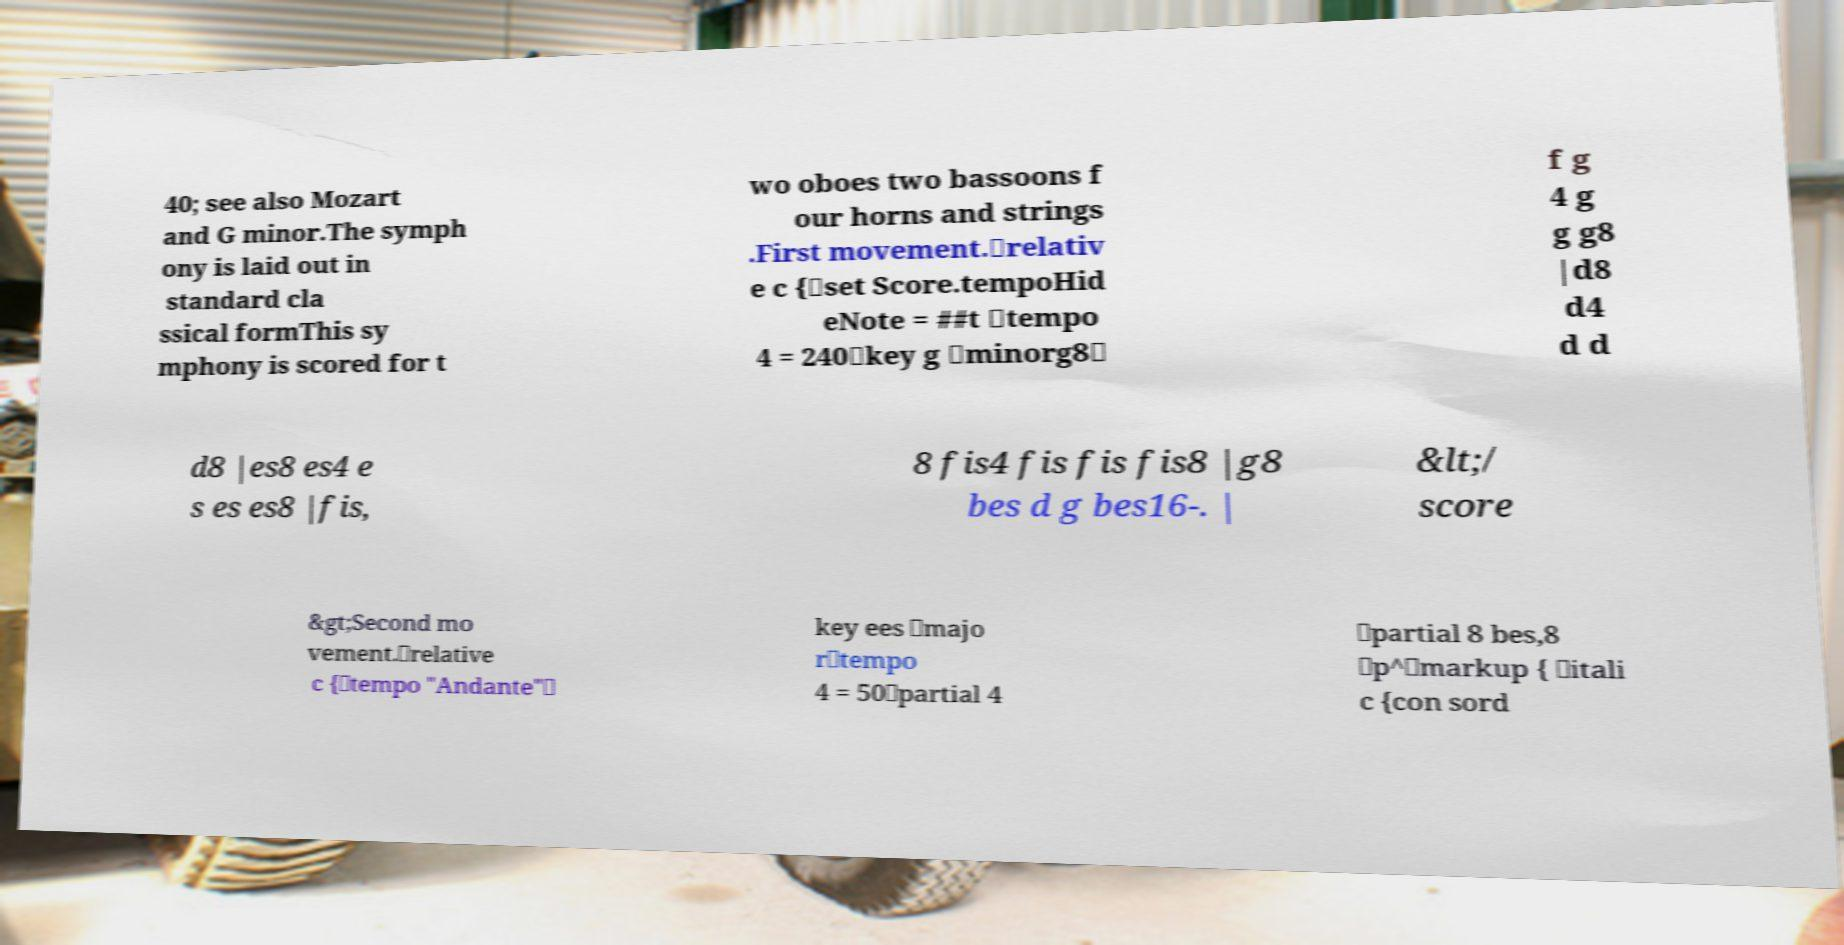What messages or text are displayed in this image? I need them in a readable, typed format. 40; see also Mozart and G minor.The symph ony is laid out in standard cla ssical formThis sy mphony is scored for t wo oboes two bassoons f our horns and strings .First movement.\relativ e c {\set Score.tempoHid eNote = ##t \tempo 4 = 240\key g \minorg8\ f g 4 g g g8 |d8 d4 d d d8 |es8 es4 e s es es8 |fis, 8 fis4 fis fis fis8 |g8 bes d g bes16-. | &lt;/ score &gt;Second mo vement.\relative c {\tempo "Andante"\ key ees \majo r\tempo 4 = 50\partial 4 \partial 8 bes,8 \p^\markup { \itali c {con sord 